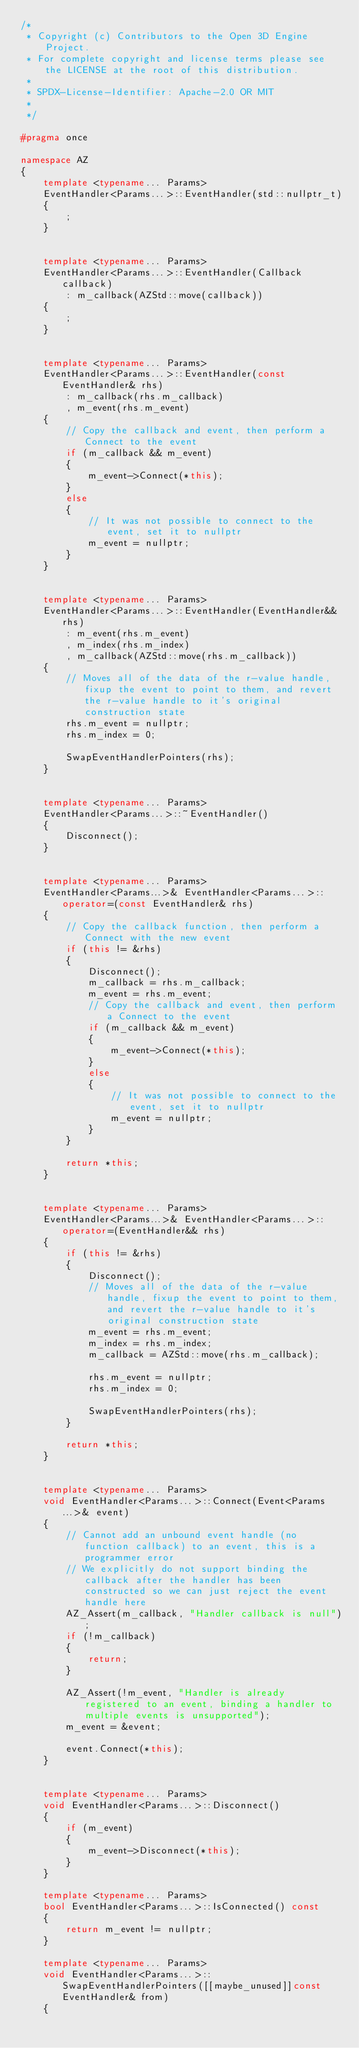Convert code to text. <code><loc_0><loc_0><loc_500><loc_500><_C++_>/*
 * Copyright (c) Contributors to the Open 3D Engine Project.
 * For complete copyright and license terms please see the LICENSE at the root of this distribution.
 *
 * SPDX-License-Identifier: Apache-2.0 OR MIT
 *
 */

#pragma once

namespace AZ
{
    template <typename... Params>
    EventHandler<Params...>::EventHandler(std::nullptr_t)
    {
        ;
    }


    template <typename... Params>
    EventHandler<Params...>::EventHandler(Callback callback)
        : m_callback(AZStd::move(callback))
    {
        ;
    }


    template <typename... Params>
    EventHandler<Params...>::EventHandler(const EventHandler& rhs)
        : m_callback(rhs.m_callback)
        , m_event(rhs.m_event)
    {
        // Copy the callback and event, then perform a Connect to the event
        if (m_callback && m_event)
        {
            m_event->Connect(*this);
        }
        else
        {
            // It was not possible to connect to the event, set it to nullptr
            m_event = nullptr;
        }
    }


    template <typename... Params>
    EventHandler<Params...>::EventHandler(EventHandler&& rhs)
        : m_event(rhs.m_event)
        , m_index(rhs.m_index)
        , m_callback(AZStd::move(rhs.m_callback))
    {
        // Moves all of the data of the r-value handle, fixup the event to point to them, and revert the r-value handle to it's original construction state
        rhs.m_event = nullptr;
        rhs.m_index = 0;

        SwapEventHandlerPointers(rhs);
    }


    template <typename... Params>
    EventHandler<Params...>::~EventHandler()
    {
        Disconnect();
    }


    template <typename... Params>
    EventHandler<Params...>& EventHandler<Params...>::operator=(const EventHandler& rhs)
    {
        // Copy the callback function, then perform a Connect with the new event
        if (this != &rhs)
        {
            Disconnect();
            m_callback = rhs.m_callback;
            m_event = rhs.m_event;
            // Copy the callback and event, then perform a Connect to the event
            if (m_callback && m_event)
            {
                m_event->Connect(*this);
            }
            else
            {
                // It was not possible to connect to the event, set it to nullptr
                m_event = nullptr;
            }
        }

        return *this;
    }


    template <typename... Params>
    EventHandler<Params...>& EventHandler<Params...>::operator=(EventHandler&& rhs)
    {
        if (this != &rhs)
        {
            Disconnect();
            // Moves all of the data of the r-value handle, fixup the event to point to them, and revert the r-value handle to it's original construction state
            m_event = rhs.m_event;
            m_index = rhs.m_index;
            m_callback = AZStd::move(rhs.m_callback);

            rhs.m_event = nullptr;
            rhs.m_index = 0;

            SwapEventHandlerPointers(rhs);
        }

        return *this;
    }


    template <typename... Params>
    void EventHandler<Params...>::Connect(Event<Params...>& event)
    {
        // Cannot add an unbound event handle (no function callback) to an event, this is a programmer error
        // We explicitly do not support binding the callback after the handler has been constructed so we can just reject the event handle here
        AZ_Assert(m_callback, "Handler callback is null");
        if (!m_callback)
        {
            return;
        }

        AZ_Assert(!m_event, "Handler is already registered to an event, binding a handler to multiple events is unsupported");
        m_event = &event;

        event.Connect(*this);
    }


    template <typename... Params>
    void EventHandler<Params...>::Disconnect()
    {
        if (m_event)
        {
            m_event->Disconnect(*this);
        }
    }

    template <typename... Params>
    bool EventHandler<Params...>::IsConnected() const
    {
        return m_event != nullptr;
    }

    template <typename... Params>
    void EventHandler<Params...>::SwapEventHandlerPointers([[maybe_unused]]const EventHandler& from)
    {</code> 